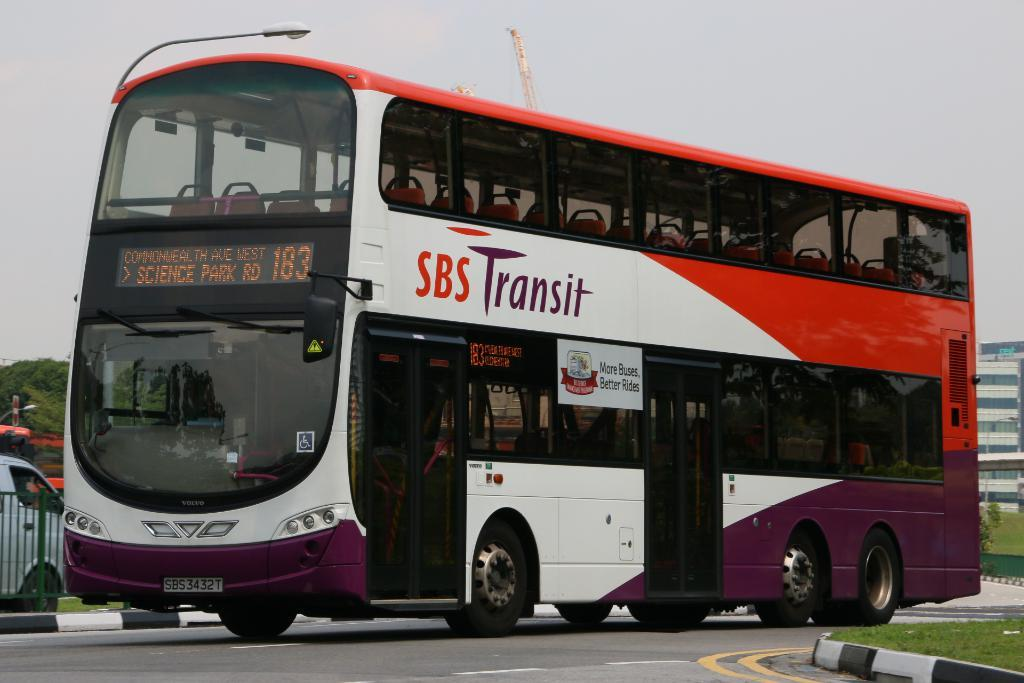What types of objects are present in the image? There are vehicles, fencing, green grass, light poles, a building, and trees in the image. Can you describe the color of the sky in the image? The sky is white in color. What type of surface is visible in the image? Green grass is visible in the image. What type of wool is being used to make the horses comfortable in the image? There are no horses or wool present in the image. How does the comfort level of the horses change throughout the day in the image? There are no horses present in the image, so it is not possible to determine their comfort level. 